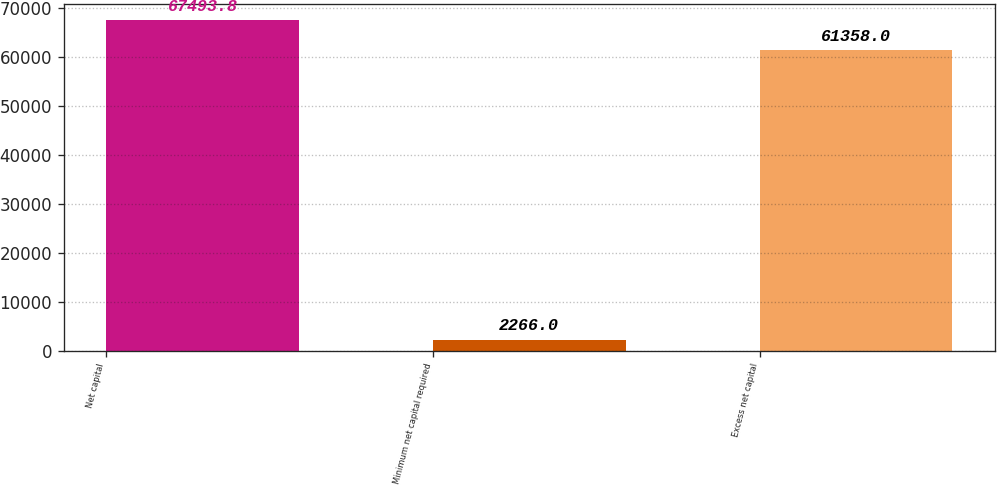Convert chart. <chart><loc_0><loc_0><loc_500><loc_500><bar_chart><fcel>Net capital<fcel>Minimum net capital required<fcel>Excess net capital<nl><fcel>67493.8<fcel>2266<fcel>61358<nl></chart> 